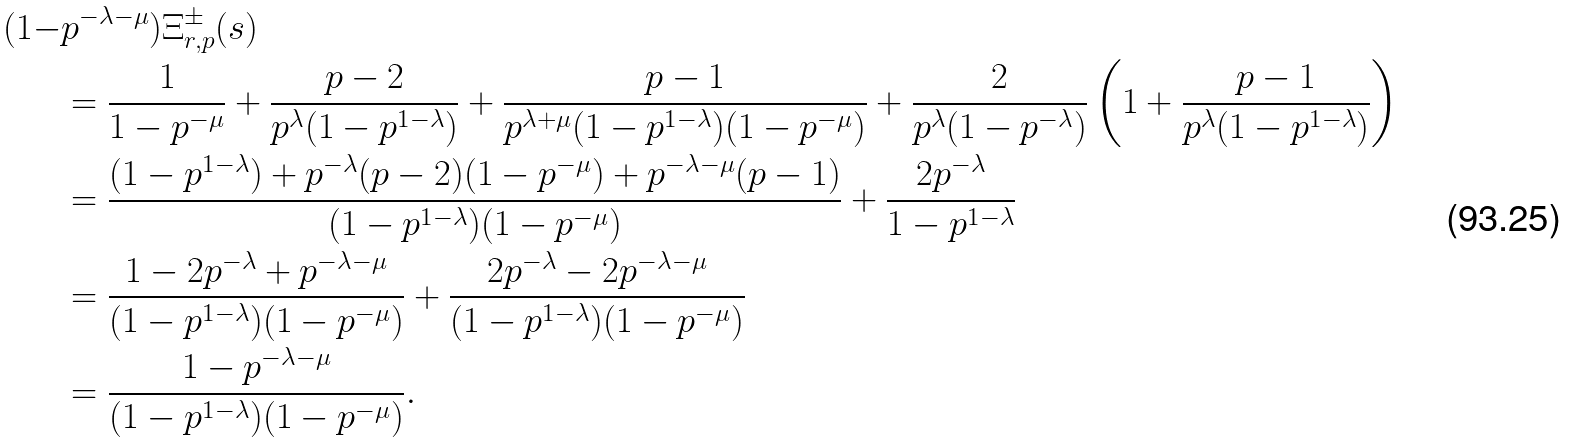<formula> <loc_0><loc_0><loc_500><loc_500>( 1 - & p ^ { - \lambda - \mu } ) \Xi _ { r , p } ^ { \pm } ( s ) \\ & = \frac { 1 } { 1 - p ^ { - \mu } } + \frac { p - 2 } { p ^ { \lambda } ( 1 - p ^ { 1 - \lambda } ) } + \frac { p - 1 } { p ^ { \lambda + \mu } ( 1 - p ^ { 1 - \lambda } ) ( 1 - p ^ { - \mu } ) } + \frac { 2 } { p ^ { \lambda } ( 1 - p ^ { - \lambda } ) } \left ( 1 + \frac { p - 1 } { p ^ { \lambda } ( 1 - p ^ { 1 - \lambda } ) } \right ) \\ & = \frac { ( 1 - p ^ { 1 - \lambda } ) + p ^ { - \lambda } ( p - 2 ) ( 1 - p ^ { - \mu } ) + p ^ { - \lambda - \mu } ( p - 1 ) } { ( 1 - p ^ { 1 - \lambda } ) ( 1 - p ^ { - \mu } ) } + \frac { 2 p ^ { - \lambda } } { 1 - p ^ { 1 - \lambda } } \\ & = \frac { 1 - 2 p ^ { - \lambda } + p ^ { - \lambda - \mu } } { ( 1 - p ^ { 1 - \lambda } ) ( 1 - p ^ { - \mu } ) } + \frac { 2 p ^ { - \lambda } - 2 p ^ { - \lambda - \mu } } { ( 1 - p ^ { 1 - \lambda } ) ( 1 - p ^ { - \mu } ) } \\ & = \frac { 1 - p ^ { - \lambda - \mu } } { ( 1 - p ^ { 1 - \lambda } ) ( 1 - p ^ { - \mu } ) } .</formula> 